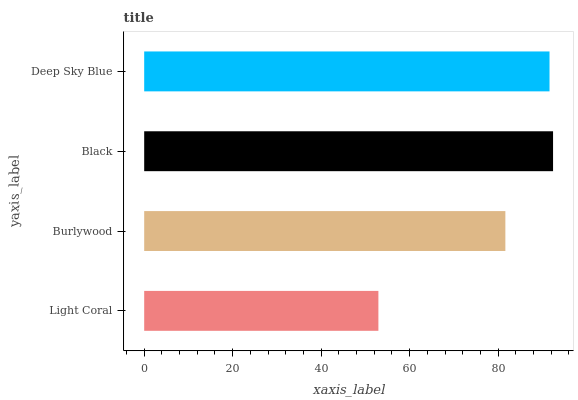Is Light Coral the minimum?
Answer yes or no. Yes. Is Black the maximum?
Answer yes or no. Yes. Is Burlywood the minimum?
Answer yes or no. No. Is Burlywood the maximum?
Answer yes or no. No. Is Burlywood greater than Light Coral?
Answer yes or no. Yes. Is Light Coral less than Burlywood?
Answer yes or no. Yes. Is Light Coral greater than Burlywood?
Answer yes or no. No. Is Burlywood less than Light Coral?
Answer yes or no. No. Is Deep Sky Blue the high median?
Answer yes or no. Yes. Is Burlywood the low median?
Answer yes or no. Yes. Is Black the high median?
Answer yes or no. No. Is Light Coral the low median?
Answer yes or no. No. 